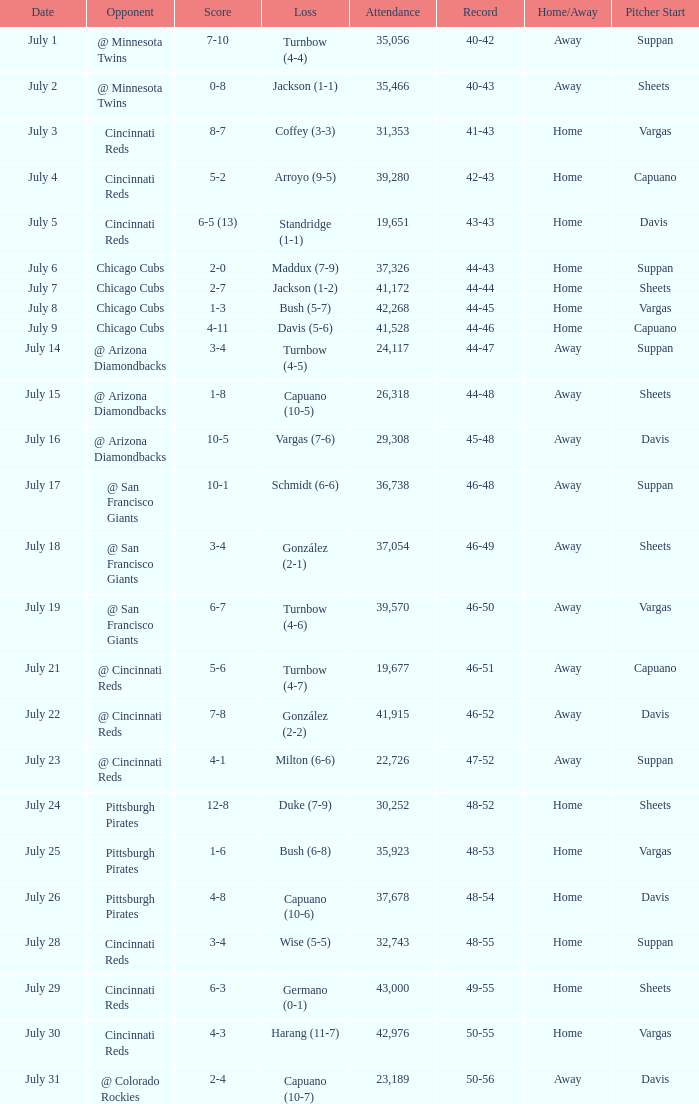Give me the full table as a dictionary. {'header': ['Date', 'Opponent', 'Score', 'Loss', 'Attendance', 'Record', 'Home/Away', 'Pitcher Start'], 'rows': [['July 1', '@ Minnesota Twins', '7-10', 'Turnbow (4-4)', '35,056', '40-42', 'Away', 'Suppan'], ['July 2', '@ Minnesota Twins', '0-8', 'Jackson (1-1)', '35,466', '40-43', 'Away', 'Sheets '], ['July 3', 'Cincinnati Reds', '8-7', 'Coffey (3-3)', '31,353', '41-43', 'Home', 'Vargas'], ['July 4', 'Cincinnati Reds', '5-2', 'Arroyo (9-5)', '39,280', '42-43', 'Home', 'Capuano'], ['July 5', 'Cincinnati Reds', '6-5 (13)', 'Standridge (1-1)', '19,651', '43-43', 'Home', 'Davis '], ['July 6', 'Chicago Cubs', '2-0', 'Maddux (7-9)', '37,326', '44-43', 'Home', 'Suppan'], ['July 7', 'Chicago Cubs', '2-7', 'Jackson (1-2)', '41,172', '44-44', 'Home', 'Sheets'], ['July 8', 'Chicago Cubs', '1-3', 'Bush (5-7)', '42,268', '44-45', 'Home', 'Vargas'], ['July 9', 'Chicago Cubs', '4-11', 'Davis (5-6)', '41,528', '44-46', 'Home', 'Capuano'], ['July 14', '@ Arizona Diamondbacks', '3-4', 'Turnbow (4-5)', '24,117', '44-47', 'Away', 'Suppan'], ['July 15', '@ Arizona Diamondbacks', '1-8', 'Capuano (10-5)', '26,318', '44-48', 'Away', 'Sheets'], ['July 16', '@ Arizona Diamondbacks', '10-5', 'Vargas (7-6)', '29,308', '45-48', 'Away', 'Davis'], ['July 17', '@ San Francisco Giants', '10-1', 'Schmidt (6-6)', '36,738', '46-48', 'Away', 'Suppan'], ['July 18', '@ San Francisco Giants', '3-4', 'González (2-1)', '37,054', '46-49', 'Away', 'Sheets'], ['July 19', '@ San Francisco Giants', '6-7', 'Turnbow (4-6)', '39,570', '46-50', 'Away', 'Vargas'], ['July 21', '@ Cincinnati Reds', '5-6', 'Turnbow (4-7)', '19,677', '46-51', 'Away', 'Capuano'], ['July 22', '@ Cincinnati Reds', '7-8', 'González (2-2)', '41,915', '46-52', 'Away', 'Davis'], ['July 23', '@ Cincinnati Reds', '4-1', 'Milton (6-6)', '22,726', '47-52', 'Away', 'Suppan'], ['July 24', 'Pittsburgh Pirates', '12-8', 'Duke (7-9)', '30,252', '48-52', 'Home', 'Sheets'], ['July 25', 'Pittsburgh Pirates', '1-6', 'Bush (6-8)', '35,923', '48-53', 'Home', 'Vargas'], ['July 26', 'Pittsburgh Pirates', '4-8', 'Capuano (10-6)', '37,678', '48-54', 'Home', 'Davis'], ['July 28', 'Cincinnati Reds', '3-4', 'Wise (5-5)', '32,743', '48-55', 'Home', 'Suppan'], ['July 29', 'Cincinnati Reds', '6-3', 'Germano (0-1)', '43,000', '49-55', 'Home', 'Sheets'], ['July 30', 'Cincinnati Reds', '4-3', 'Harang (11-7)', '42,976', '50-55', 'Home', 'Vargas'], ['July 31', '@ Colorado Rockies', '2-4', 'Capuano (10-7)', '23,189', '50-56', 'Away', 'Davis']]} What was the loss of the Brewers game when the record was 46-48? Schmidt (6-6). 